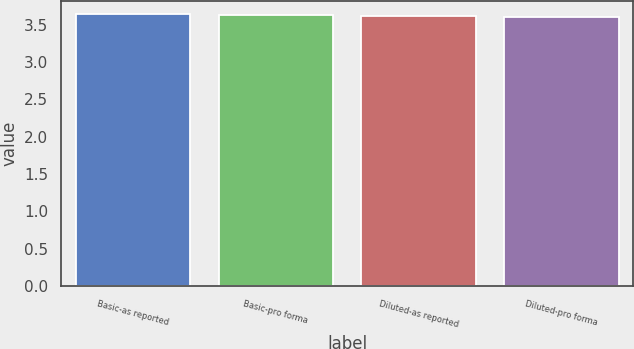Convert chart to OTSL. <chart><loc_0><loc_0><loc_500><loc_500><bar_chart><fcel>Basic-as reported<fcel>Basic-pro forma<fcel>Diluted-as reported<fcel>Diluted-pro forma<nl><fcel>3.64<fcel>3.63<fcel>3.61<fcel>3.6<nl></chart> 